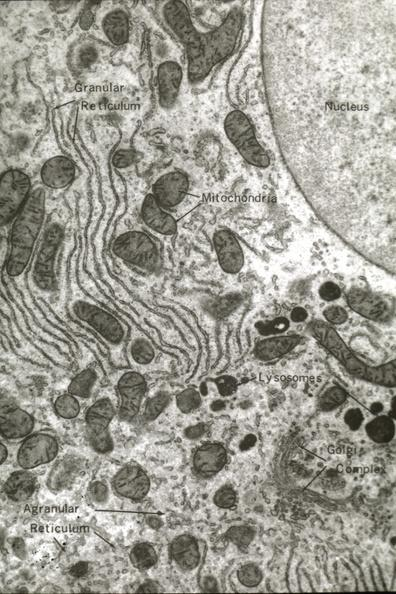does this image show structures labeled?
Answer the question using a single word or phrase. Yes 